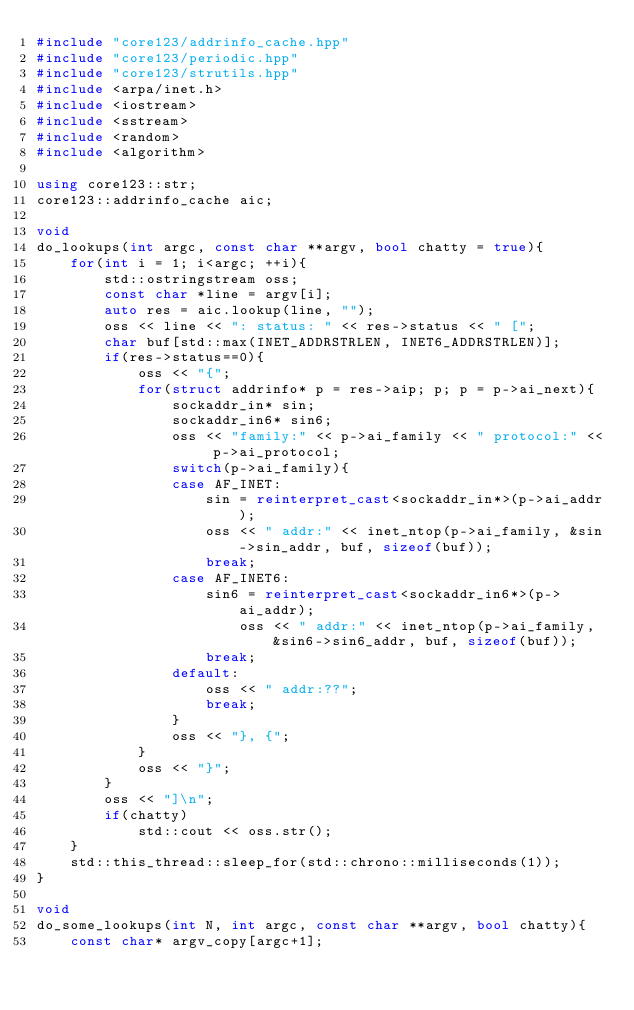<code> <loc_0><loc_0><loc_500><loc_500><_C++_>#include "core123/addrinfo_cache.hpp"
#include "core123/periodic.hpp"
#include "core123/strutils.hpp"
#include <arpa/inet.h>
#include <iostream>
#include <sstream>
#include <random>
#include <algorithm>

using core123::str;
core123::addrinfo_cache aic;

void
do_lookups(int argc, const char **argv, bool chatty = true){
    for(int i = 1; i<argc; ++i){
        std::ostringstream oss;
        const char *line = argv[i];
        auto res = aic.lookup(line, "");
        oss << line << ": status: " << res->status << " [";
        char buf[std::max(INET_ADDRSTRLEN, INET6_ADDRSTRLEN)];
        if(res->status==0){
            oss << "{";
            for(struct addrinfo* p = res->aip; p; p = p->ai_next){
                sockaddr_in* sin;
                sockaddr_in6* sin6;
                oss << "family:" << p->ai_family << " protocol:" << p->ai_protocol;
                switch(p->ai_family){
                case AF_INET:
                    sin = reinterpret_cast<sockaddr_in*>(p->ai_addr);
                    oss << " addr:" << inet_ntop(p->ai_family, &sin->sin_addr, buf, sizeof(buf));
                    break;
                case AF_INET6:
                    sin6 = reinterpret_cast<sockaddr_in6*>(p->ai_addr);
                        oss << " addr:" << inet_ntop(p->ai_family, &sin6->sin6_addr, buf, sizeof(buf));
                    break;
                default:
                    oss << " addr:??";
                    break;
                }
                oss << "}, {";
            }
            oss << "}";
        }
        oss << "]\n";
        if(chatty)
            std::cout << oss.str();
    }
    std::this_thread::sleep_for(std::chrono::milliseconds(1));
}

void
do_some_lookups(int N, int argc, const char **argv, bool chatty){
    const char* argv_copy[argc+1];</code> 